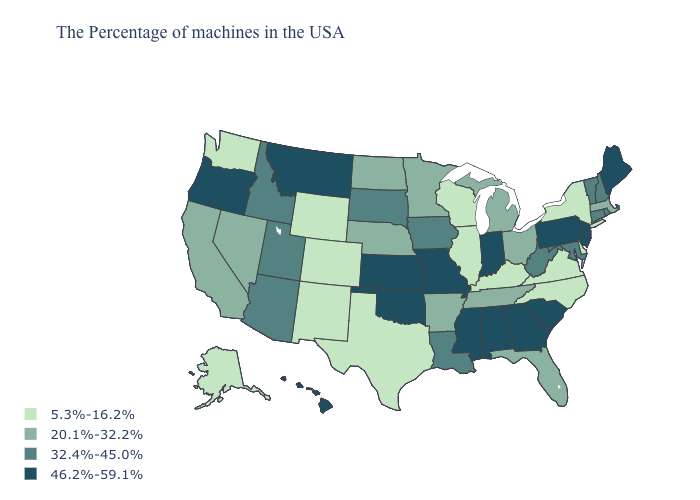What is the value of Florida?
Give a very brief answer. 20.1%-32.2%. Which states have the lowest value in the Northeast?
Write a very short answer. New York. What is the lowest value in the USA?
Quick response, please. 5.3%-16.2%. Does Wyoming have the lowest value in the USA?
Give a very brief answer. Yes. What is the lowest value in the USA?
Be succinct. 5.3%-16.2%. Among the states that border Louisiana , which have the lowest value?
Short answer required. Texas. What is the value of New Mexico?
Concise answer only. 5.3%-16.2%. What is the value of Minnesota?
Be succinct. 20.1%-32.2%. Name the states that have a value in the range 5.3%-16.2%?
Give a very brief answer. New York, Delaware, Virginia, North Carolina, Kentucky, Wisconsin, Illinois, Texas, Wyoming, Colorado, New Mexico, Washington, Alaska. Does North Dakota have a higher value than Wyoming?
Answer briefly. Yes. What is the value of New Hampshire?
Quick response, please. 32.4%-45.0%. Does the map have missing data?
Give a very brief answer. No. Name the states that have a value in the range 20.1%-32.2%?
Give a very brief answer. Massachusetts, Ohio, Florida, Michigan, Tennessee, Arkansas, Minnesota, Nebraska, North Dakota, Nevada, California. Name the states that have a value in the range 20.1%-32.2%?
Quick response, please. Massachusetts, Ohio, Florida, Michigan, Tennessee, Arkansas, Minnesota, Nebraska, North Dakota, Nevada, California. Does Kansas have the highest value in the USA?
Quick response, please. Yes. 